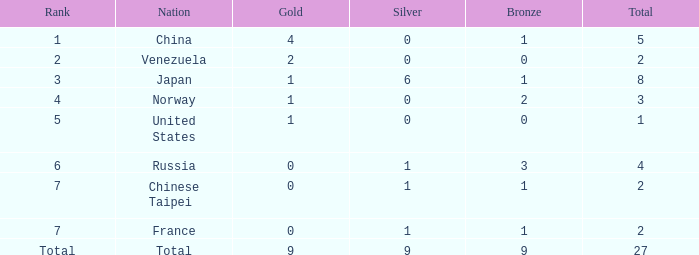What is the sum of Bronze when the total is more than 27? None. 